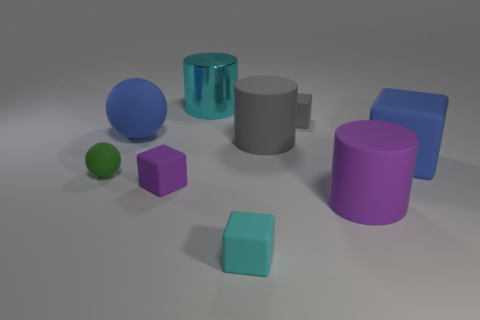Subtract all large blue cubes. How many cubes are left? 3 Subtract all gray cylinders. How many cylinders are left? 2 Subtract 3 blocks. How many blocks are left? 1 Subtract all cubes. How many objects are left? 5 Subtract all large blocks. Subtract all brown shiny spheres. How many objects are left? 8 Add 4 gray rubber cubes. How many gray rubber cubes are left? 5 Add 2 big rubber things. How many big rubber things exist? 6 Subtract 0 purple spheres. How many objects are left? 9 Subtract all purple cubes. Subtract all purple balls. How many cubes are left? 3 